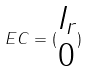Convert formula to latex. <formula><loc_0><loc_0><loc_500><loc_500>E C = ( \begin{matrix} I _ { r } \\ 0 \end{matrix} )</formula> 